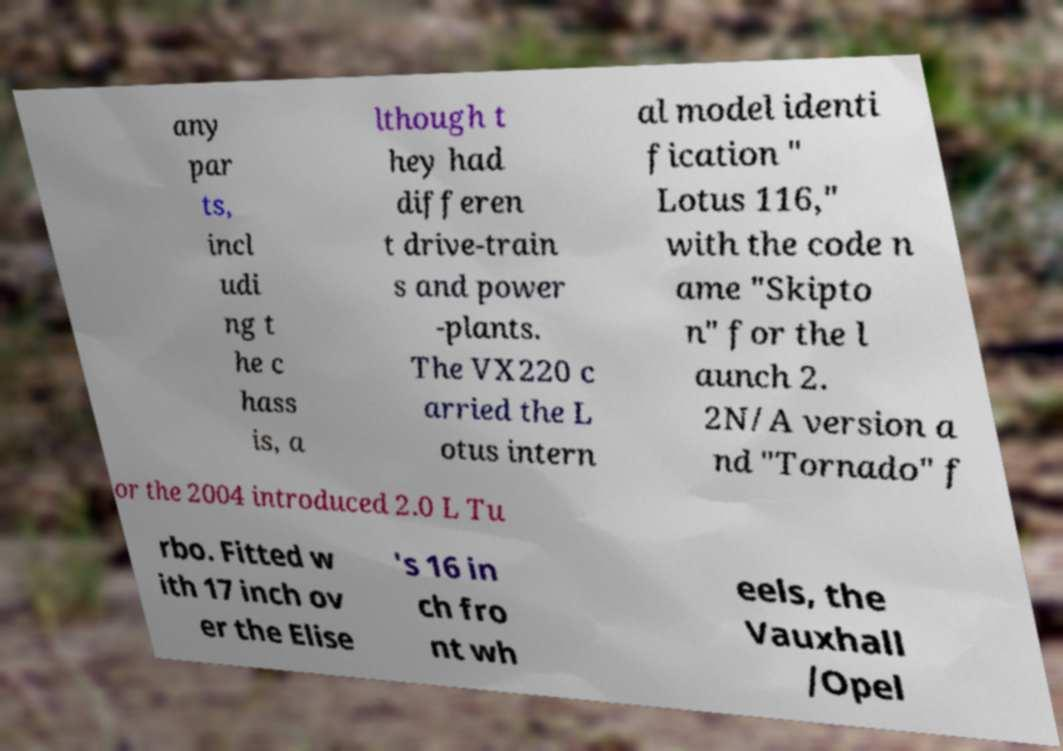There's text embedded in this image that I need extracted. Can you transcribe it verbatim? any par ts, incl udi ng t he c hass is, a lthough t hey had differen t drive-train s and power -plants. The VX220 c arried the L otus intern al model identi fication " Lotus 116," with the code n ame "Skipto n" for the l aunch 2. 2N/A version a nd "Tornado" f or the 2004 introduced 2.0 L Tu rbo. Fitted w ith 17 inch ov er the Elise 's 16 in ch fro nt wh eels, the Vauxhall /Opel 